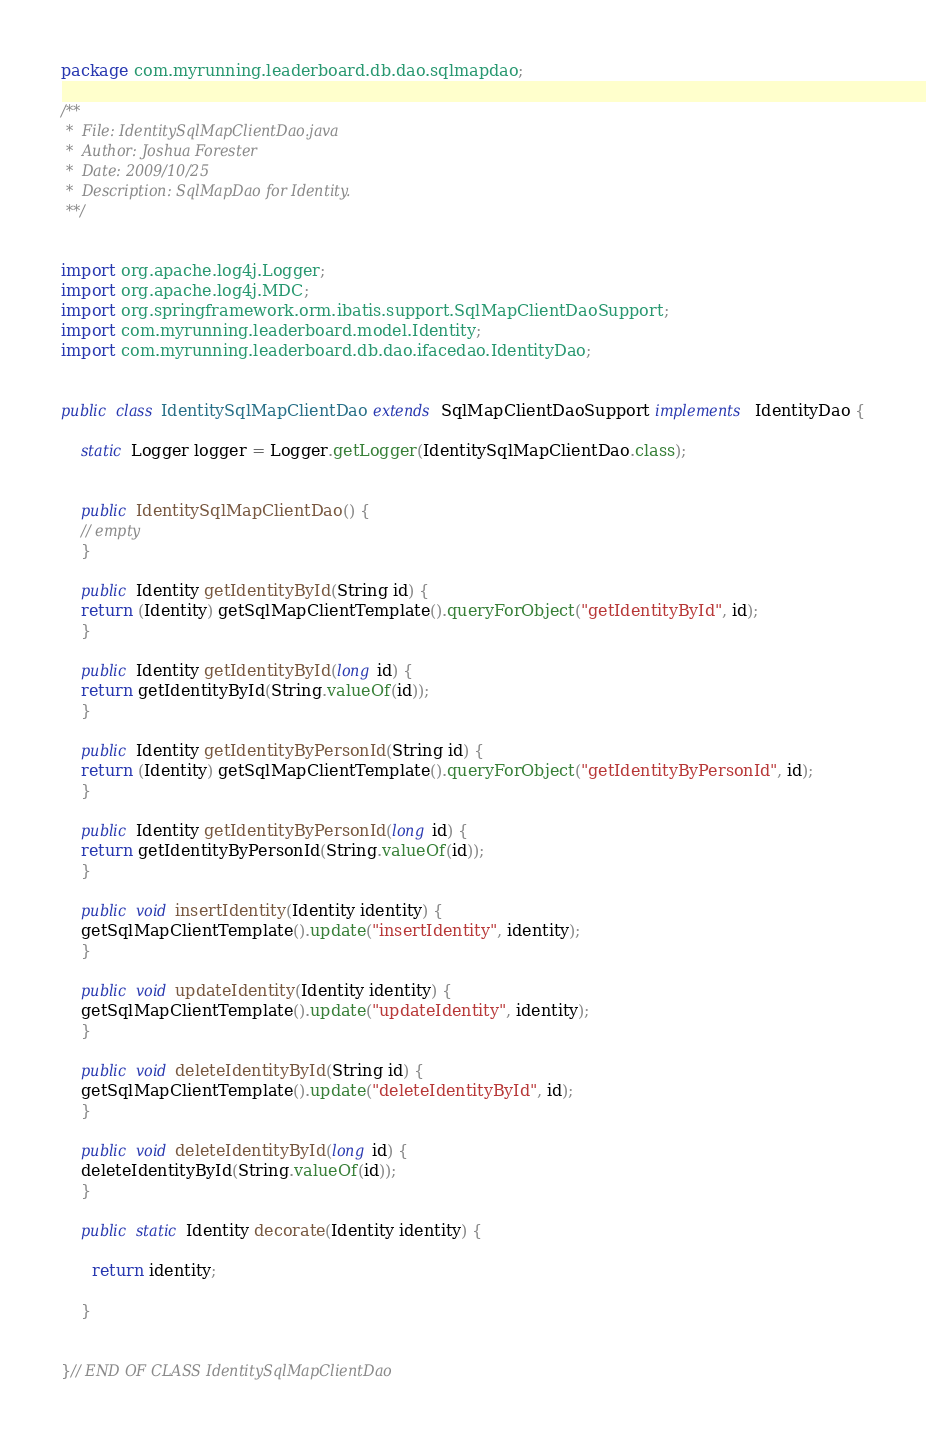<code> <loc_0><loc_0><loc_500><loc_500><_Java_>package com.myrunning.leaderboard.db.dao.sqlmapdao;

/**
 *  File: IdentitySqlMapClientDao.java
 *  Author: Joshua Forester
 *  Date: 2009/10/25
 *  Description: SqlMapDao for Identity.
 **/


import org.apache.log4j.Logger;
import org.apache.log4j.MDC;
import org.springframework.orm.ibatis.support.SqlMapClientDaoSupport;
import com.myrunning.leaderboard.model.Identity;
import com.myrunning.leaderboard.db.dao.ifacedao.IdentityDao;


public class IdentitySqlMapClientDao extends SqlMapClientDaoSupport implements IdentityDao {

    static Logger logger = Logger.getLogger(IdentitySqlMapClientDao.class);


    public IdentitySqlMapClientDao() {
	// empty
    }

    public Identity getIdentityById(String id) {
	return (Identity) getSqlMapClientTemplate().queryForObject("getIdentityById", id);
    }

    public Identity getIdentityById(long id) {
	return getIdentityById(String.valueOf(id));
    }

    public Identity getIdentityByPersonId(String id) {
	return (Identity) getSqlMapClientTemplate().queryForObject("getIdentityByPersonId", id);
    }

    public Identity getIdentityByPersonId(long id) {
	return getIdentityByPersonId(String.valueOf(id));
    }

    public void insertIdentity(Identity identity) {
	getSqlMapClientTemplate().update("insertIdentity", identity);
    }

    public void updateIdentity(Identity identity) {
	getSqlMapClientTemplate().update("updateIdentity", identity);
    }

    public void deleteIdentityById(String id) {
	getSqlMapClientTemplate().update("deleteIdentityById", id);
    }

    public void deleteIdentityById(long id) {
	deleteIdentityById(String.valueOf(id));
    }

    public static Identity decorate(Identity identity) {

      return identity;

    }


}// END OF CLASS IdentitySqlMapClientDao
</code> 